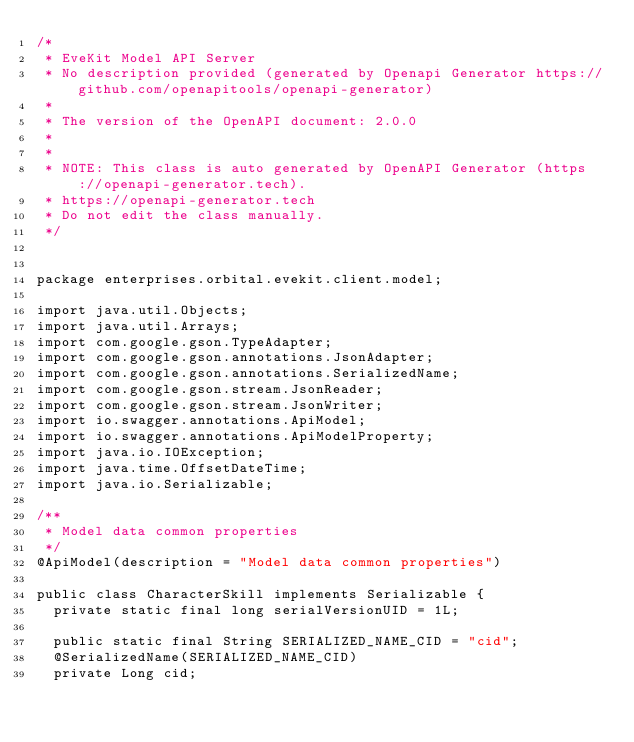Convert code to text. <code><loc_0><loc_0><loc_500><loc_500><_Java_>/*
 * EveKit Model API Server
 * No description provided (generated by Openapi Generator https://github.com/openapitools/openapi-generator)
 *
 * The version of the OpenAPI document: 2.0.0
 * 
 *
 * NOTE: This class is auto generated by OpenAPI Generator (https://openapi-generator.tech).
 * https://openapi-generator.tech
 * Do not edit the class manually.
 */


package enterprises.orbital.evekit.client.model;

import java.util.Objects;
import java.util.Arrays;
import com.google.gson.TypeAdapter;
import com.google.gson.annotations.JsonAdapter;
import com.google.gson.annotations.SerializedName;
import com.google.gson.stream.JsonReader;
import com.google.gson.stream.JsonWriter;
import io.swagger.annotations.ApiModel;
import io.swagger.annotations.ApiModelProperty;
import java.io.IOException;
import java.time.OffsetDateTime;
import java.io.Serializable;

/**
 * Model data common properties
 */
@ApiModel(description = "Model data common properties")

public class CharacterSkill implements Serializable {
  private static final long serialVersionUID = 1L;

  public static final String SERIALIZED_NAME_CID = "cid";
  @SerializedName(SERIALIZED_NAME_CID)
  private Long cid;
</code> 